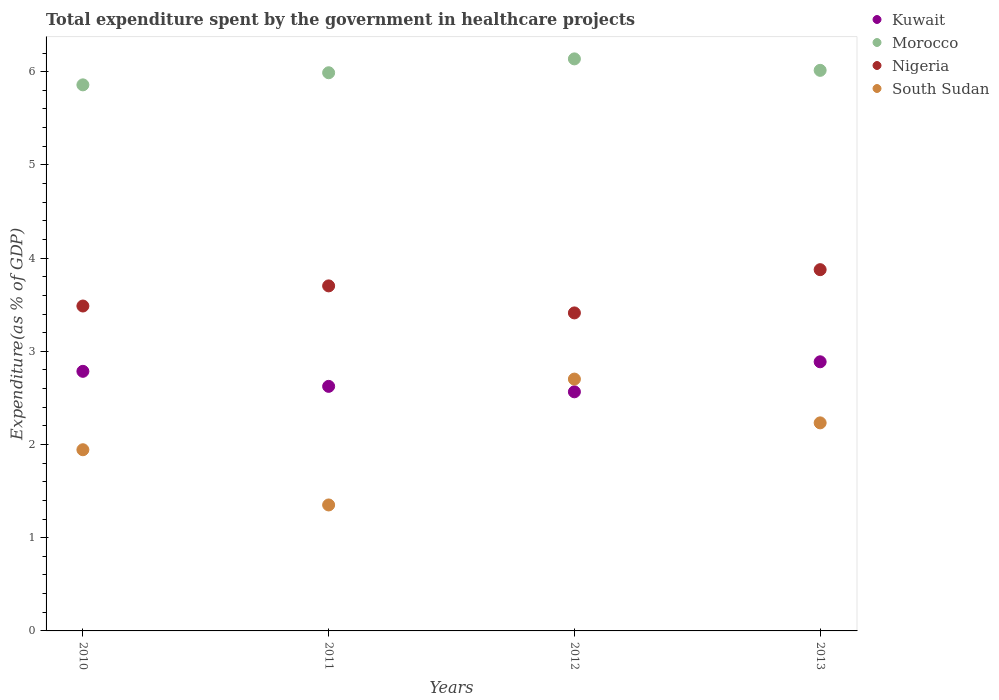How many different coloured dotlines are there?
Your answer should be compact. 4. Is the number of dotlines equal to the number of legend labels?
Keep it short and to the point. Yes. What is the total expenditure spent by the government in healthcare projects in Kuwait in 2013?
Offer a very short reply. 2.89. Across all years, what is the maximum total expenditure spent by the government in healthcare projects in Morocco?
Your answer should be very brief. 6.14. Across all years, what is the minimum total expenditure spent by the government in healthcare projects in Nigeria?
Your response must be concise. 3.41. In which year was the total expenditure spent by the government in healthcare projects in South Sudan maximum?
Your answer should be compact. 2012. What is the total total expenditure spent by the government in healthcare projects in Morocco in the graph?
Make the answer very short. 24. What is the difference between the total expenditure spent by the government in healthcare projects in Morocco in 2012 and that in 2013?
Provide a short and direct response. 0.12. What is the difference between the total expenditure spent by the government in healthcare projects in Nigeria in 2011 and the total expenditure spent by the government in healthcare projects in Kuwait in 2010?
Make the answer very short. 0.92. What is the average total expenditure spent by the government in healthcare projects in Nigeria per year?
Ensure brevity in your answer.  3.62. In the year 2011, what is the difference between the total expenditure spent by the government in healthcare projects in Nigeria and total expenditure spent by the government in healthcare projects in Kuwait?
Give a very brief answer. 1.08. In how many years, is the total expenditure spent by the government in healthcare projects in South Sudan greater than 5.4 %?
Offer a very short reply. 0. What is the ratio of the total expenditure spent by the government in healthcare projects in Morocco in 2010 to that in 2013?
Keep it short and to the point. 0.97. What is the difference between the highest and the second highest total expenditure spent by the government in healthcare projects in Kuwait?
Your response must be concise. 0.1. What is the difference between the highest and the lowest total expenditure spent by the government in healthcare projects in Kuwait?
Provide a succinct answer. 0.32. In how many years, is the total expenditure spent by the government in healthcare projects in South Sudan greater than the average total expenditure spent by the government in healthcare projects in South Sudan taken over all years?
Your answer should be very brief. 2. Is the sum of the total expenditure spent by the government in healthcare projects in South Sudan in 2010 and 2013 greater than the maximum total expenditure spent by the government in healthcare projects in Morocco across all years?
Offer a very short reply. No. Does the total expenditure spent by the government in healthcare projects in Kuwait monotonically increase over the years?
Provide a short and direct response. No. Is the total expenditure spent by the government in healthcare projects in Morocco strictly greater than the total expenditure spent by the government in healthcare projects in Kuwait over the years?
Offer a very short reply. Yes. How many years are there in the graph?
Your answer should be very brief. 4. Are the values on the major ticks of Y-axis written in scientific E-notation?
Make the answer very short. No. How many legend labels are there?
Offer a very short reply. 4. How are the legend labels stacked?
Provide a short and direct response. Vertical. What is the title of the graph?
Provide a short and direct response. Total expenditure spent by the government in healthcare projects. Does "Georgia" appear as one of the legend labels in the graph?
Make the answer very short. No. What is the label or title of the X-axis?
Ensure brevity in your answer.  Years. What is the label or title of the Y-axis?
Your response must be concise. Expenditure(as % of GDP). What is the Expenditure(as % of GDP) of Kuwait in 2010?
Offer a very short reply. 2.79. What is the Expenditure(as % of GDP) of Morocco in 2010?
Give a very brief answer. 5.86. What is the Expenditure(as % of GDP) in Nigeria in 2010?
Your answer should be compact. 3.49. What is the Expenditure(as % of GDP) of South Sudan in 2010?
Keep it short and to the point. 1.94. What is the Expenditure(as % of GDP) of Kuwait in 2011?
Your answer should be compact. 2.62. What is the Expenditure(as % of GDP) of Morocco in 2011?
Keep it short and to the point. 5.99. What is the Expenditure(as % of GDP) of Nigeria in 2011?
Offer a terse response. 3.7. What is the Expenditure(as % of GDP) of South Sudan in 2011?
Your answer should be very brief. 1.35. What is the Expenditure(as % of GDP) of Kuwait in 2012?
Provide a short and direct response. 2.57. What is the Expenditure(as % of GDP) of Morocco in 2012?
Your answer should be compact. 6.14. What is the Expenditure(as % of GDP) in Nigeria in 2012?
Provide a short and direct response. 3.41. What is the Expenditure(as % of GDP) of South Sudan in 2012?
Offer a terse response. 2.7. What is the Expenditure(as % of GDP) in Kuwait in 2013?
Your response must be concise. 2.89. What is the Expenditure(as % of GDP) of Morocco in 2013?
Ensure brevity in your answer.  6.01. What is the Expenditure(as % of GDP) in Nigeria in 2013?
Give a very brief answer. 3.88. What is the Expenditure(as % of GDP) in South Sudan in 2013?
Offer a very short reply. 2.23. Across all years, what is the maximum Expenditure(as % of GDP) of Kuwait?
Provide a short and direct response. 2.89. Across all years, what is the maximum Expenditure(as % of GDP) of Morocco?
Your answer should be compact. 6.14. Across all years, what is the maximum Expenditure(as % of GDP) in Nigeria?
Your response must be concise. 3.88. Across all years, what is the maximum Expenditure(as % of GDP) of South Sudan?
Offer a terse response. 2.7. Across all years, what is the minimum Expenditure(as % of GDP) of Kuwait?
Your answer should be very brief. 2.57. Across all years, what is the minimum Expenditure(as % of GDP) in Morocco?
Ensure brevity in your answer.  5.86. Across all years, what is the minimum Expenditure(as % of GDP) of Nigeria?
Offer a very short reply. 3.41. Across all years, what is the minimum Expenditure(as % of GDP) in South Sudan?
Your response must be concise. 1.35. What is the total Expenditure(as % of GDP) of Kuwait in the graph?
Your response must be concise. 10.86. What is the total Expenditure(as % of GDP) in Morocco in the graph?
Give a very brief answer. 24. What is the total Expenditure(as % of GDP) of Nigeria in the graph?
Provide a succinct answer. 14.48. What is the total Expenditure(as % of GDP) of South Sudan in the graph?
Your answer should be compact. 8.23. What is the difference between the Expenditure(as % of GDP) of Kuwait in 2010 and that in 2011?
Make the answer very short. 0.16. What is the difference between the Expenditure(as % of GDP) in Morocco in 2010 and that in 2011?
Your answer should be compact. -0.13. What is the difference between the Expenditure(as % of GDP) of Nigeria in 2010 and that in 2011?
Give a very brief answer. -0.22. What is the difference between the Expenditure(as % of GDP) of South Sudan in 2010 and that in 2011?
Give a very brief answer. 0.59. What is the difference between the Expenditure(as % of GDP) in Kuwait in 2010 and that in 2012?
Ensure brevity in your answer.  0.22. What is the difference between the Expenditure(as % of GDP) of Morocco in 2010 and that in 2012?
Keep it short and to the point. -0.28. What is the difference between the Expenditure(as % of GDP) in Nigeria in 2010 and that in 2012?
Ensure brevity in your answer.  0.07. What is the difference between the Expenditure(as % of GDP) in South Sudan in 2010 and that in 2012?
Make the answer very short. -0.76. What is the difference between the Expenditure(as % of GDP) in Kuwait in 2010 and that in 2013?
Offer a very short reply. -0.1. What is the difference between the Expenditure(as % of GDP) in Morocco in 2010 and that in 2013?
Provide a succinct answer. -0.16. What is the difference between the Expenditure(as % of GDP) in Nigeria in 2010 and that in 2013?
Your response must be concise. -0.39. What is the difference between the Expenditure(as % of GDP) in South Sudan in 2010 and that in 2013?
Your answer should be very brief. -0.29. What is the difference between the Expenditure(as % of GDP) of Kuwait in 2011 and that in 2012?
Your response must be concise. 0.06. What is the difference between the Expenditure(as % of GDP) in Morocco in 2011 and that in 2012?
Your answer should be very brief. -0.15. What is the difference between the Expenditure(as % of GDP) of Nigeria in 2011 and that in 2012?
Offer a very short reply. 0.29. What is the difference between the Expenditure(as % of GDP) in South Sudan in 2011 and that in 2012?
Your answer should be compact. -1.35. What is the difference between the Expenditure(as % of GDP) in Kuwait in 2011 and that in 2013?
Offer a very short reply. -0.26. What is the difference between the Expenditure(as % of GDP) in Morocco in 2011 and that in 2013?
Make the answer very short. -0.03. What is the difference between the Expenditure(as % of GDP) of Nigeria in 2011 and that in 2013?
Provide a short and direct response. -0.17. What is the difference between the Expenditure(as % of GDP) in South Sudan in 2011 and that in 2013?
Provide a succinct answer. -0.88. What is the difference between the Expenditure(as % of GDP) in Kuwait in 2012 and that in 2013?
Ensure brevity in your answer.  -0.32. What is the difference between the Expenditure(as % of GDP) in Morocco in 2012 and that in 2013?
Make the answer very short. 0.12. What is the difference between the Expenditure(as % of GDP) in Nigeria in 2012 and that in 2013?
Ensure brevity in your answer.  -0.46. What is the difference between the Expenditure(as % of GDP) in South Sudan in 2012 and that in 2013?
Make the answer very short. 0.47. What is the difference between the Expenditure(as % of GDP) of Kuwait in 2010 and the Expenditure(as % of GDP) of Morocco in 2011?
Provide a succinct answer. -3.2. What is the difference between the Expenditure(as % of GDP) in Kuwait in 2010 and the Expenditure(as % of GDP) in Nigeria in 2011?
Keep it short and to the point. -0.92. What is the difference between the Expenditure(as % of GDP) in Kuwait in 2010 and the Expenditure(as % of GDP) in South Sudan in 2011?
Offer a terse response. 1.43. What is the difference between the Expenditure(as % of GDP) in Morocco in 2010 and the Expenditure(as % of GDP) in Nigeria in 2011?
Provide a short and direct response. 2.16. What is the difference between the Expenditure(as % of GDP) in Morocco in 2010 and the Expenditure(as % of GDP) in South Sudan in 2011?
Give a very brief answer. 4.51. What is the difference between the Expenditure(as % of GDP) of Nigeria in 2010 and the Expenditure(as % of GDP) of South Sudan in 2011?
Offer a terse response. 2.13. What is the difference between the Expenditure(as % of GDP) of Kuwait in 2010 and the Expenditure(as % of GDP) of Morocco in 2012?
Give a very brief answer. -3.35. What is the difference between the Expenditure(as % of GDP) in Kuwait in 2010 and the Expenditure(as % of GDP) in Nigeria in 2012?
Provide a succinct answer. -0.63. What is the difference between the Expenditure(as % of GDP) of Kuwait in 2010 and the Expenditure(as % of GDP) of South Sudan in 2012?
Offer a terse response. 0.08. What is the difference between the Expenditure(as % of GDP) in Morocco in 2010 and the Expenditure(as % of GDP) in Nigeria in 2012?
Your answer should be very brief. 2.45. What is the difference between the Expenditure(as % of GDP) in Morocco in 2010 and the Expenditure(as % of GDP) in South Sudan in 2012?
Offer a terse response. 3.16. What is the difference between the Expenditure(as % of GDP) in Nigeria in 2010 and the Expenditure(as % of GDP) in South Sudan in 2012?
Make the answer very short. 0.78. What is the difference between the Expenditure(as % of GDP) in Kuwait in 2010 and the Expenditure(as % of GDP) in Morocco in 2013?
Offer a terse response. -3.23. What is the difference between the Expenditure(as % of GDP) in Kuwait in 2010 and the Expenditure(as % of GDP) in Nigeria in 2013?
Provide a short and direct response. -1.09. What is the difference between the Expenditure(as % of GDP) in Kuwait in 2010 and the Expenditure(as % of GDP) in South Sudan in 2013?
Your answer should be compact. 0.55. What is the difference between the Expenditure(as % of GDP) in Morocco in 2010 and the Expenditure(as % of GDP) in Nigeria in 2013?
Ensure brevity in your answer.  1.98. What is the difference between the Expenditure(as % of GDP) in Morocco in 2010 and the Expenditure(as % of GDP) in South Sudan in 2013?
Ensure brevity in your answer.  3.63. What is the difference between the Expenditure(as % of GDP) in Nigeria in 2010 and the Expenditure(as % of GDP) in South Sudan in 2013?
Make the answer very short. 1.25. What is the difference between the Expenditure(as % of GDP) in Kuwait in 2011 and the Expenditure(as % of GDP) in Morocco in 2012?
Make the answer very short. -3.51. What is the difference between the Expenditure(as % of GDP) of Kuwait in 2011 and the Expenditure(as % of GDP) of Nigeria in 2012?
Your answer should be compact. -0.79. What is the difference between the Expenditure(as % of GDP) in Kuwait in 2011 and the Expenditure(as % of GDP) in South Sudan in 2012?
Give a very brief answer. -0.08. What is the difference between the Expenditure(as % of GDP) in Morocco in 2011 and the Expenditure(as % of GDP) in Nigeria in 2012?
Give a very brief answer. 2.58. What is the difference between the Expenditure(as % of GDP) of Morocco in 2011 and the Expenditure(as % of GDP) of South Sudan in 2012?
Your answer should be compact. 3.29. What is the difference between the Expenditure(as % of GDP) of Nigeria in 2011 and the Expenditure(as % of GDP) of South Sudan in 2012?
Offer a very short reply. 1. What is the difference between the Expenditure(as % of GDP) of Kuwait in 2011 and the Expenditure(as % of GDP) of Morocco in 2013?
Your response must be concise. -3.39. What is the difference between the Expenditure(as % of GDP) of Kuwait in 2011 and the Expenditure(as % of GDP) of Nigeria in 2013?
Your answer should be compact. -1.25. What is the difference between the Expenditure(as % of GDP) of Kuwait in 2011 and the Expenditure(as % of GDP) of South Sudan in 2013?
Provide a short and direct response. 0.39. What is the difference between the Expenditure(as % of GDP) in Morocco in 2011 and the Expenditure(as % of GDP) in Nigeria in 2013?
Give a very brief answer. 2.11. What is the difference between the Expenditure(as % of GDP) in Morocco in 2011 and the Expenditure(as % of GDP) in South Sudan in 2013?
Give a very brief answer. 3.76. What is the difference between the Expenditure(as % of GDP) of Nigeria in 2011 and the Expenditure(as % of GDP) of South Sudan in 2013?
Ensure brevity in your answer.  1.47. What is the difference between the Expenditure(as % of GDP) of Kuwait in 2012 and the Expenditure(as % of GDP) of Morocco in 2013?
Your answer should be very brief. -3.45. What is the difference between the Expenditure(as % of GDP) in Kuwait in 2012 and the Expenditure(as % of GDP) in Nigeria in 2013?
Your answer should be very brief. -1.31. What is the difference between the Expenditure(as % of GDP) in Kuwait in 2012 and the Expenditure(as % of GDP) in South Sudan in 2013?
Make the answer very short. 0.33. What is the difference between the Expenditure(as % of GDP) of Morocco in 2012 and the Expenditure(as % of GDP) of Nigeria in 2013?
Offer a very short reply. 2.26. What is the difference between the Expenditure(as % of GDP) of Morocco in 2012 and the Expenditure(as % of GDP) of South Sudan in 2013?
Provide a short and direct response. 3.91. What is the difference between the Expenditure(as % of GDP) in Nigeria in 2012 and the Expenditure(as % of GDP) in South Sudan in 2013?
Give a very brief answer. 1.18. What is the average Expenditure(as % of GDP) of Kuwait per year?
Provide a short and direct response. 2.72. What is the average Expenditure(as % of GDP) in Morocco per year?
Make the answer very short. 6. What is the average Expenditure(as % of GDP) of Nigeria per year?
Give a very brief answer. 3.62. What is the average Expenditure(as % of GDP) in South Sudan per year?
Provide a short and direct response. 2.06. In the year 2010, what is the difference between the Expenditure(as % of GDP) in Kuwait and Expenditure(as % of GDP) in Morocco?
Offer a very short reply. -3.07. In the year 2010, what is the difference between the Expenditure(as % of GDP) in Kuwait and Expenditure(as % of GDP) in Nigeria?
Make the answer very short. -0.7. In the year 2010, what is the difference between the Expenditure(as % of GDP) in Kuwait and Expenditure(as % of GDP) in South Sudan?
Make the answer very short. 0.84. In the year 2010, what is the difference between the Expenditure(as % of GDP) in Morocco and Expenditure(as % of GDP) in Nigeria?
Keep it short and to the point. 2.37. In the year 2010, what is the difference between the Expenditure(as % of GDP) in Morocco and Expenditure(as % of GDP) in South Sudan?
Make the answer very short. 3.91. In the year 2010, what is the difference between the Expenditure(as % of GDP) of Nigeria and Expenditure(as % of GDP) of South Sudan?
Give a very brief answer. 1.54. In the year 2011, what is the difference between the Expenditure(as % of GDP) of Kuwait and Expenditure(as % of GDP) of Morocco?
Give a very brief answer. -3.36. In the year 2011, what is the difference between the Expenditure(as % of GDP) of Kuwait and Expenditure(as % of GDP) of Nigeria?
Your response must be concise. -1.08. In the year 2011, what is the difference between the Expenditure(as % of GDP) in Kuwait and Expenditure(as % of GDP) in South Sudan?
Keep it short and to the point. 1.27. In the year 2011, what is the difference between the Expenditure(as % of GDP) of Morocco and Expenditure(as % of GDP) of Nigeria?
Provide a succinct answer. 2.29. In the year 2011, what is the difference between the Expenditure(as % of GDP) in Morocco and Expenditure(as % of GDP) in South Sudan?
Provide a short and direct response. 4.64. In the year 2011, what is the difference between the Expenditure(as % of GDP) in Nigeria and Expenditure(as % of GDP) in South Sudan?
Your answer should be compact. 2.35. In the year 2012, what is the difference between the Expenditure(as % of GDP) in Kuwait and Expenditure(as % of GDP) in Morocco?
Your answer should be compact. -3.57. In the year 2012, what is the difference between the Expenditure(as % of GDP) in Kuwait and Expenditure(as % of GDP) in Nigeria?
Provide a short and direct response. -0.85. In the year 2012, what is the difference between the Expenditure(as % of GDP) of Kuwait and Expenditure(as % of GDP) of South Sudan?
Provide a short and direct response. -0.14. In the year 2012, what is the difference between the Expenditure(as % of GDP) in Morocco and Expenditure(as % of GDP) in Nigeria?
Your response must be concise. 2.73. In the year 2012, what is the difference between the Expenditure(as % of GDP) of Morocco and Expenditure(as % of GDP) of South Sudan?
Your answer should be very brief. 3.44. In the year 2012, what is the difference between the Expenditure(as % of GDP) in Nigeria and Expenditure(as % of GDP) in South Sudan?
Keep it short and to the point. 0.71. In the year 2013, what is the difference between the Expenditure(as % of GDP) of Kuwait and Expenditure(as % of GDP) of Morocco?
Provide a succinct answer. -3.13. In the year 2013, what is the difference between the Expenditure(as % of GDP) of Kuwait and Expenditure(as % of GDP) of Nigeria?
Give a very brief answer. -0.99. In the year 2013, what is the difference between the Expenditure(as % of GDP) in Kuwait and Expenditure(as % of GDP) in South Sudan?
Make the answer very short. 0.66. In the year 2013, what is the difference between the Expenditure(as % of GDP) of Morocco and Expenditure(as % of GDP) of Nigeria?
Provide a succinct answer. 2.14. In the year 2013, what is the difference between the Expenditure(as % of GDP) of Morocco and Expenditure(as % of GDP) of South Sudan?
Provide a succinct answer. 3.78. In the year 2013, what is the difference between the Expenditure(as % of GDP) of Nigeria and Expenditure(as % of GDP) of South Sudan?
Provide a short and direct response. 1.64. What is the ratio of the Expenditure(as % of GDP) in Kuwait in 2010 to that in 2011?
Provide a succinct answer. 1.06. What is the ratio of the Expenditure(as % of GDP) in Morocco in 2010 to that in 2011?
Offer a terse response. 0.98. What is the ratio of the Expenditure(as % of GDP) in Nigeria in 2010 to that in 2011?
Your answer should be very brief. 0.94. What is the ratio of the Expenditure(as % of GDP) in South Sudan in 2010 to that in 2011?
Ensure brevity in your answer.  1.44. What is the ratio of the Expenditure(as % of GDP) in Kuwait in 2010 to that in 2012?
Provide a succinct answer. 1.09. What is the ratio of the Expenditure(as % of GDP) of Morocco in 2010 to that in 2012?
Offer a terse response. 0.95. What is the ratio of the Expenditure(as % of GDP) of Nigeria in 2010 to that in 2012?
Your answer should be very brief. 1.02. What is the ratio of the Expenditure(as % of GDP) in South Sudan in 2010 to that in 2012?
Keep it short and to the point. 0.72. What is the ratio of the Expenditure(as % of GDP) in Kuwait in 2010 to that in 2013?
Ensure brevity in your answer.  0.96. What is the ratio of the Expenditure(as % of GDP) in Morocco in 2010 to that in 2013?
Make the answer very short. 0.97. What is the ratio of the Expenditure(as % of GDP) in Nigeria in 2010 to that in 2013?
Provide a succinct answer. 0.9. What is the ratio of the Expenditure(as % of GDP) of South Sudan in 2010 to that in 2013?
Offer a very short reply. 0.87. What is the ratio of the Expenditure(as % of GDP) of Kuwait in 2011 to that in 2012?
Your answer should be very brief. 1.02. What is the ratio of the Expenditure(as % of GDP) in Morocco in 2011 to that in 2012?
Ensure brevity in your answer.  0.98. What is the ratio of the Expenditure(as % of GDP) of Nigeria in 2011 to that in 2012?
Provide a short and direct response. 1.08. What is the ratio of the Expenditure(as % of GDP) in South Sudan in 2011 to that in 2012?
Provide a succinct answer. 0.5. What is the ratio of the Expenditure(as % of GDP) of Kuwait in 2011 to that in 2013?
Your response must be concise. 0.91. What is the ratio of the Expenditure(as % of GDP) in Nigeria in 2011 to that in 2013?
Offer a terse response. 0.96. What is the ratio of the Expenditure(as % of GDP) in South Sudan in 2011 to that in 2013?
Offer a terse response. 0.61. What is the ratio of the Expenditure(as % of GDP) of Kuwait in 2012 to that in 2013?
Give a very brief answer. 0.89. What is the ratio of the Expenditure(as % of GDP) in Morocco in 2012 to that in 2013?
Ensure brevity in your answer.  1.02. What is the ratio of the Expenditure(as % of GDP) in Nigeria in 2012 to that in 2013?
Provide a short and direct response. 0.88. What is the ratio of the Expenditure(as % of GDP) in South Sudan in 2012 to that in 2013?
Your response must be concise. 1.21. What is the difference between the highest and the second highest Expenditure(as % of GDP) in Kuwait?
Offer a terse response. 0.1. What is the difference between the highest and the second highest Expenditure(as % of GDP) in Morocco?
Offer a very short reply. 0.12. What is the difference between the highest and the second highest Expenditure(as % of GDP) of Nigeria?
Make the answer very short. 0.17. What is the difference between the highest and the second highest Expenditure(as % of GDP) of South Sudan?
Your response must be concise. 0.47. What is the difference between the highest and the lowest Expenditure(as % of GDP) of Kuwait?
Offer a terse response. 0.32. What is the difference between the highest and the lowest Expenditure(as % of GDP) in Morocco?
Give a very brief answer. 0.28. What is the difference between the highest and the lowest Expenditure(as % of GDP) in Nigeria?
Offer a terse response. 0.46. What is the difference between the highest and the lowest Expenditure(as % of GDP) in South Sudan?
Your answer should be compact. 1.35. 